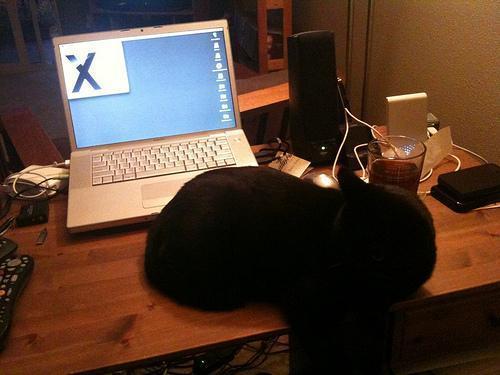How many cats are there?
Give a very brief answer. 1. 